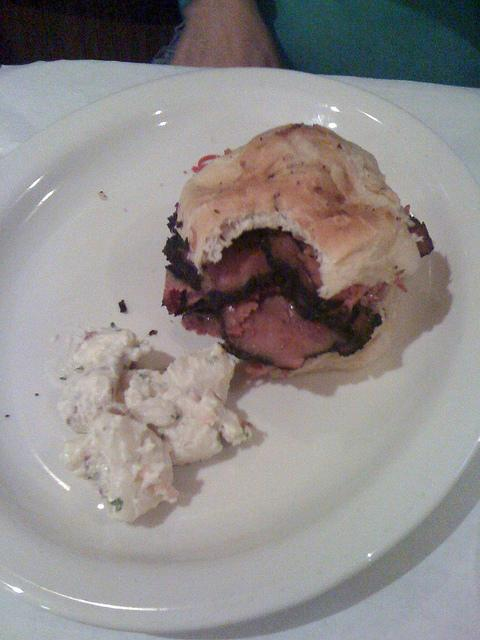What is the side dish? Please explain your reasoning. potato salad. It is chunks of potato with a creamy dressing 